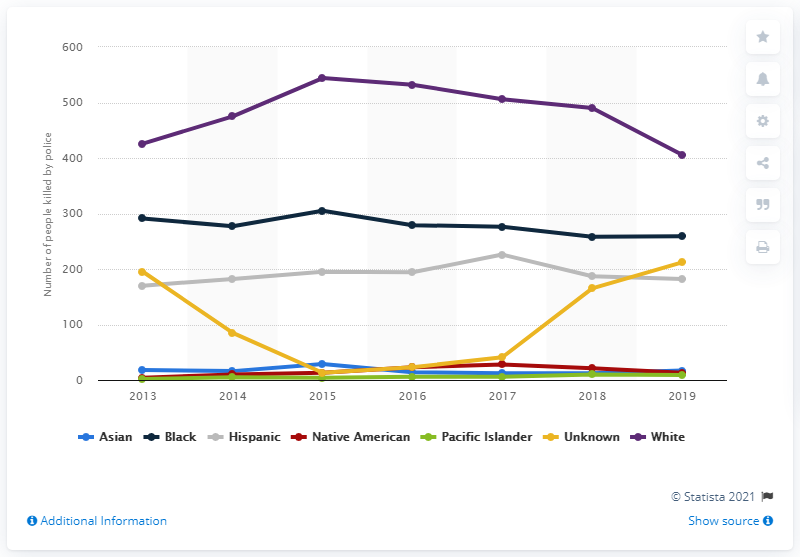Indicate a few pertinent items in this graphic. In 2019, 259 Black people were killed by police in the United States. In 2019, a total of 182 Hispanics were killed by police, according to statistics. 